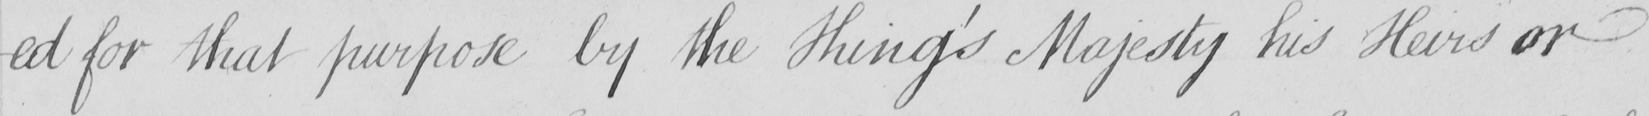What does this handwritten line say? -ed for that purpose by the King ' s Majesty his Heirs or 